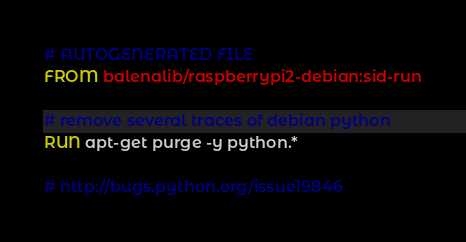Convert code to text. <code><loc_0><loc_0><loc_500><loc_500><_Dockerfile_># AUTOGENERATED FILE
FROM balenalib/raspberrypi2-debian:sid-run

# remove several traces of debian python
RUN apt-get purge -y python.*

# http://bugs.python.org/issue19846</code> 